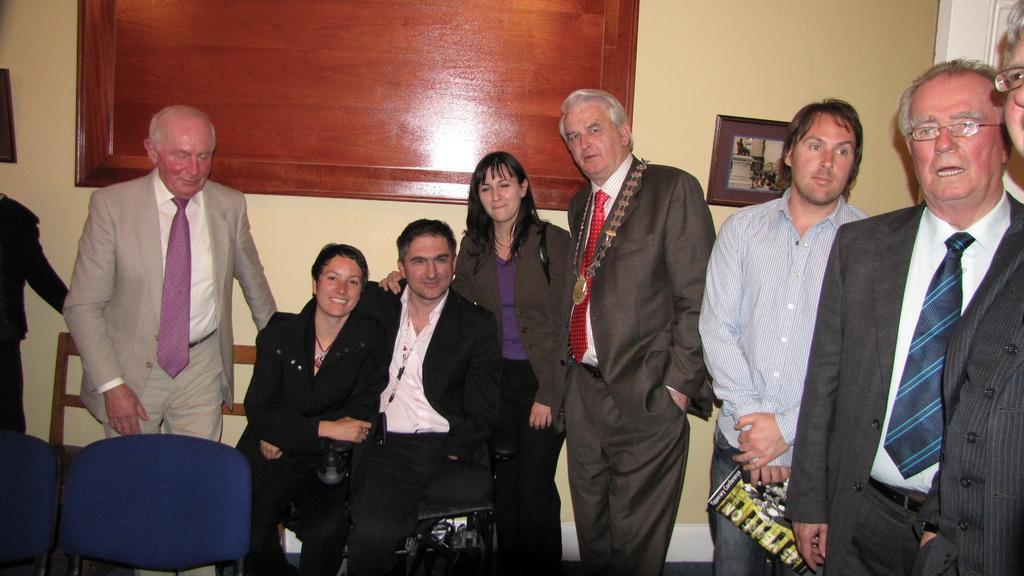Please provide a concise description of this image. In this picture we can see two persons sitting on the chairs. And this is the wall. There is a frame. Here we can see few persons standing on the floor. 